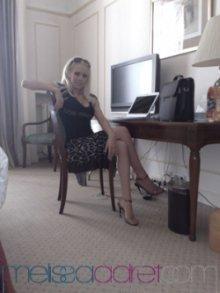How many people are there?
Give a very brief answer. 1. How many black sheep are there?
Give a very brief answer. 0. 